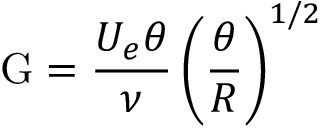<formula> <loc_0><loc_0><loc_500><loc_500>G = { \frac { U _ { e } \theta } { \nu } } \left ( { \frac { \theta } { R } } \right ) ^ { 1 / 2 }</formula> 